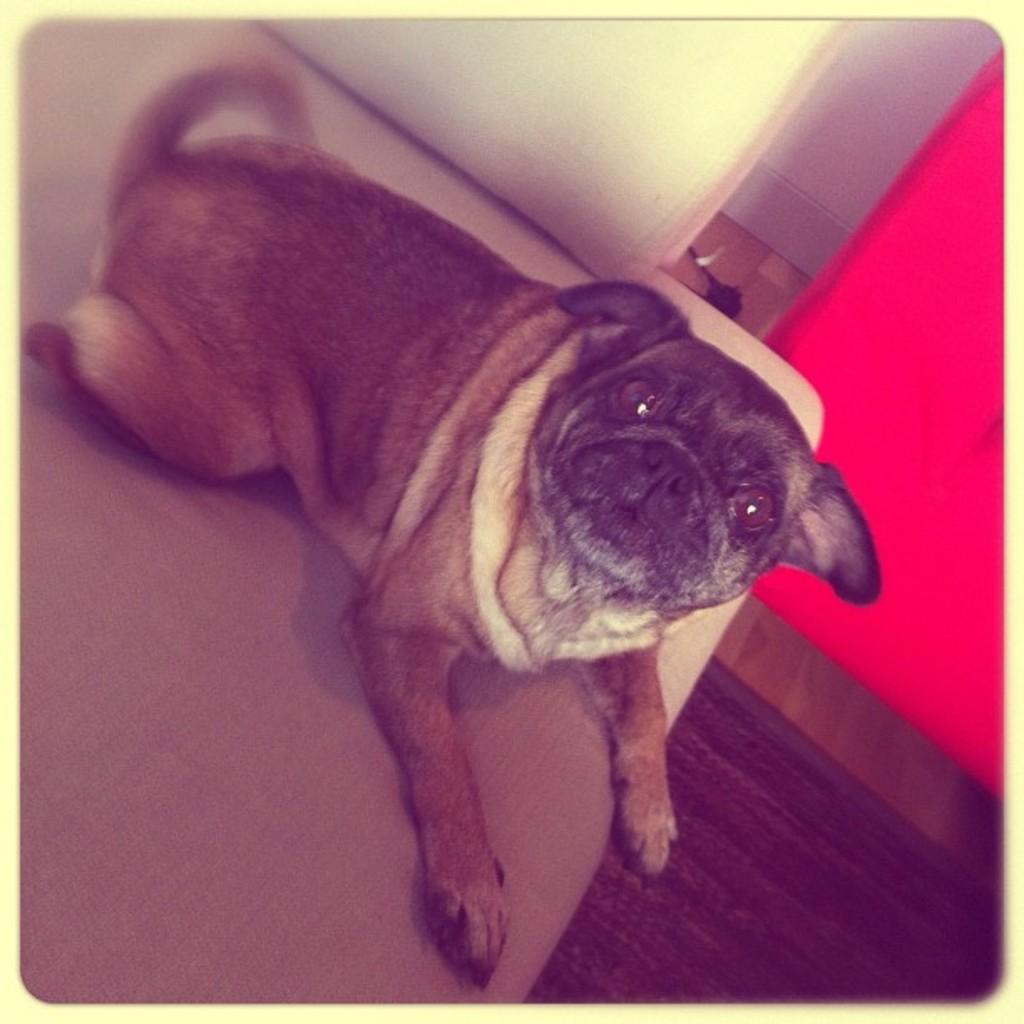What type of animal is in the image? There is a pug in the image. Where is the pug located in the image? The pug is sitting on a sofa. What color object can be seen in the right corner of the image? There is a red color object in the right corner of the image. What is the name of the hospital where the pug was born? There is no information about a hospital or the pug's birth in the image, so we cannot determine the name of the hospital. 